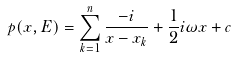<formula> <loc_0><loc_0><loc_500><loc_500>p ( x , E ) = \sum _ { k = 1 } ^ { n } \frac { - i } { x - x _ { k } } + \frac { 1 } { 2 } i \omega x + c</formula> 